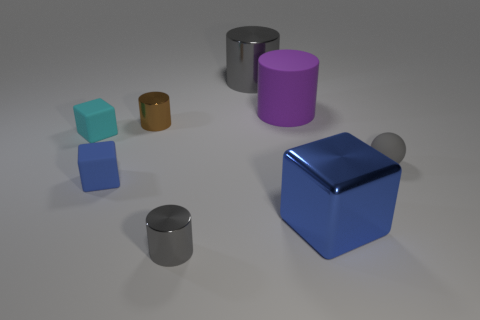Is the small sphere the same color as the big shiny cylinder?
Provide a succinct answer. Yes. There is a big metal thing in front of the small cyan object; what color is it?
Provide a succinct answer. Blue. The big gray thing is what shape?
Your answer should be compact. Cylinder. There is a small matte cube in front of the tiny object left of the small blue rubber block; is there a cylinder in front of it?
Your answer should be very brief. Yes. The matte thing behind the small metallic object that is behind the tiny gray thing that is left of the large shiny block is what color?
Your answer should be very brief. Purple. There is a big gray thing that is the same shape as the tiny brown thing; what is it made of?
Provide a succinct answer. Metal. There is a brown shiny cylinder behind the big blue thing that is in front of the cyan rubber object; what size is it?
Provide a succinct answer. Small. There is a gray cylinder in front of the big rubber thing; what is it made of?
Your answer should be compact. Metal. What is the size of the gray sphere that is the same material as the cyan cube?
Make the answer very short. Small. What number of other small things have the same shape as the tiny cyan thing?
Your answer should be compact. 1. 